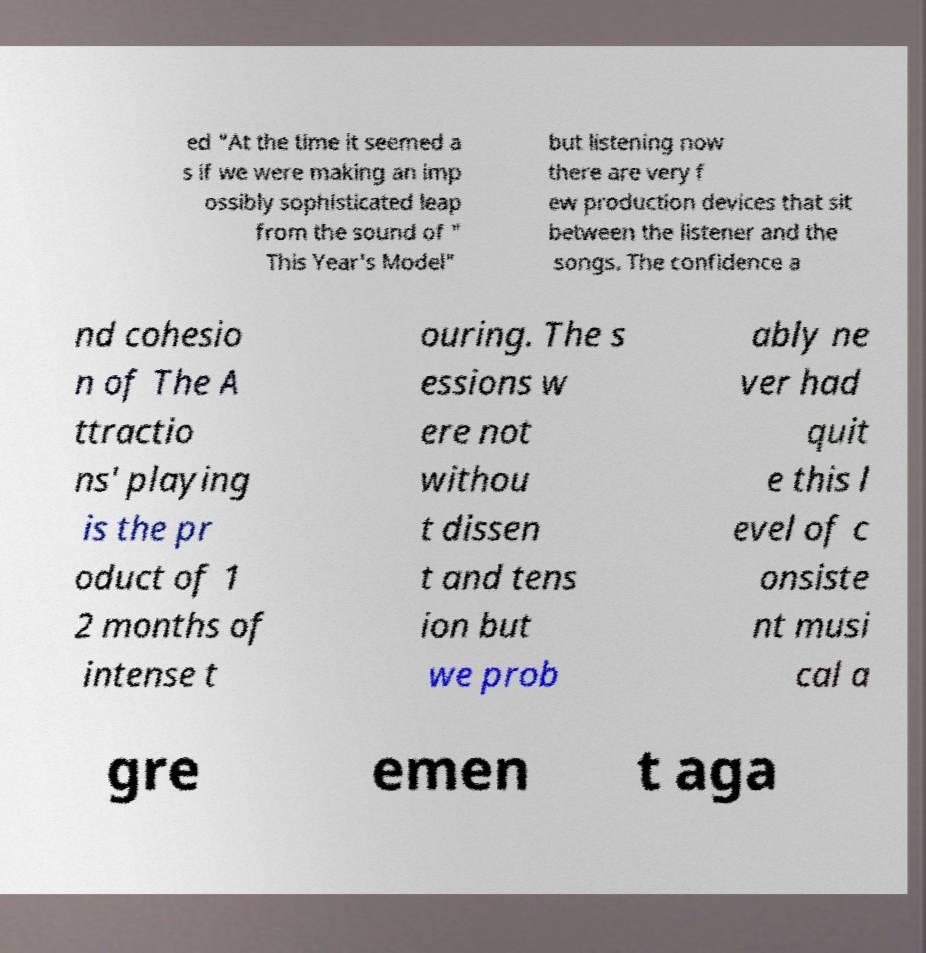Can you accurately transcribe the text from the provided image for me? ed "At the time it seemed a s if we were making an imp ossibly sophisticated leap from the sound of " This Year's Model" but listening now there are very f ew production devices that sit between the listener and the songs. The confidence a nd cohesio n of The A ttractio ns' playing is the pr oduct of 1 2 months of intense t ouring. The s essions w ere not withou t dissen t and tens ion but we prob ably ne ver had quit e this l evel of c onsiste nt musi cal a gre emen t aga 